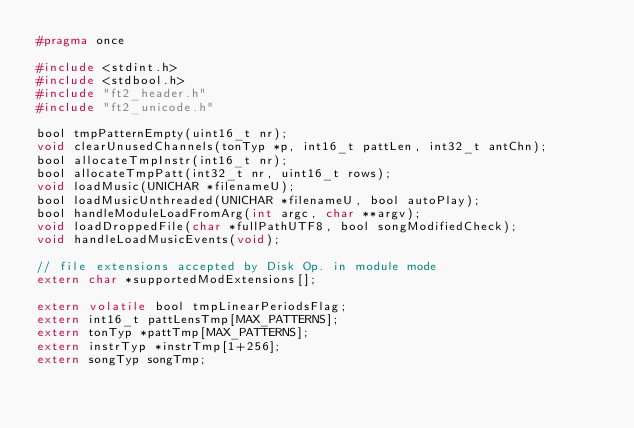<code> <loc_0><loc_0><loc_500><loc_500><_C_>#pragma once

#include <stdint.h>
#include <stdbool.h>
#include "ft2_header.h"
#include "ft2_unicode.h"

bool tmpPatternEmpty(uint16_t nr);
void clearUnusedChannels(tonTyp *p, int16_t pattLen, int32_t antChn);
bool allocateTmpInstr(int16_t nr);
bool allocateTmpPatt(int32_t nr, uint16_t rows);
void loadMusic(UNICHAR *filenameU);
bool loadMusicUnthreaded(UNICHAR *filenameU, bool autoPlay);
bool handleModuleLoadFromArg(int argc, char **argv);
void loadDroppedFile(char *fullPathUTF8, bool songModifiedCheck);
void handleLoadMusicEvents(void);

// file extensions accepted by Disk Op. in module mode
extern char *supportedModExtensions[];

extern volatile bool tmpLinearPeriodsFlag;
extern int16_t pattLensTmp[MAX_PATTERNS];
extern tonTyp *pattTmp[MAX_PATTERNS];
extern instrTyp *instrTmp[1+256];
extern songTyp songTmp;
</code> 